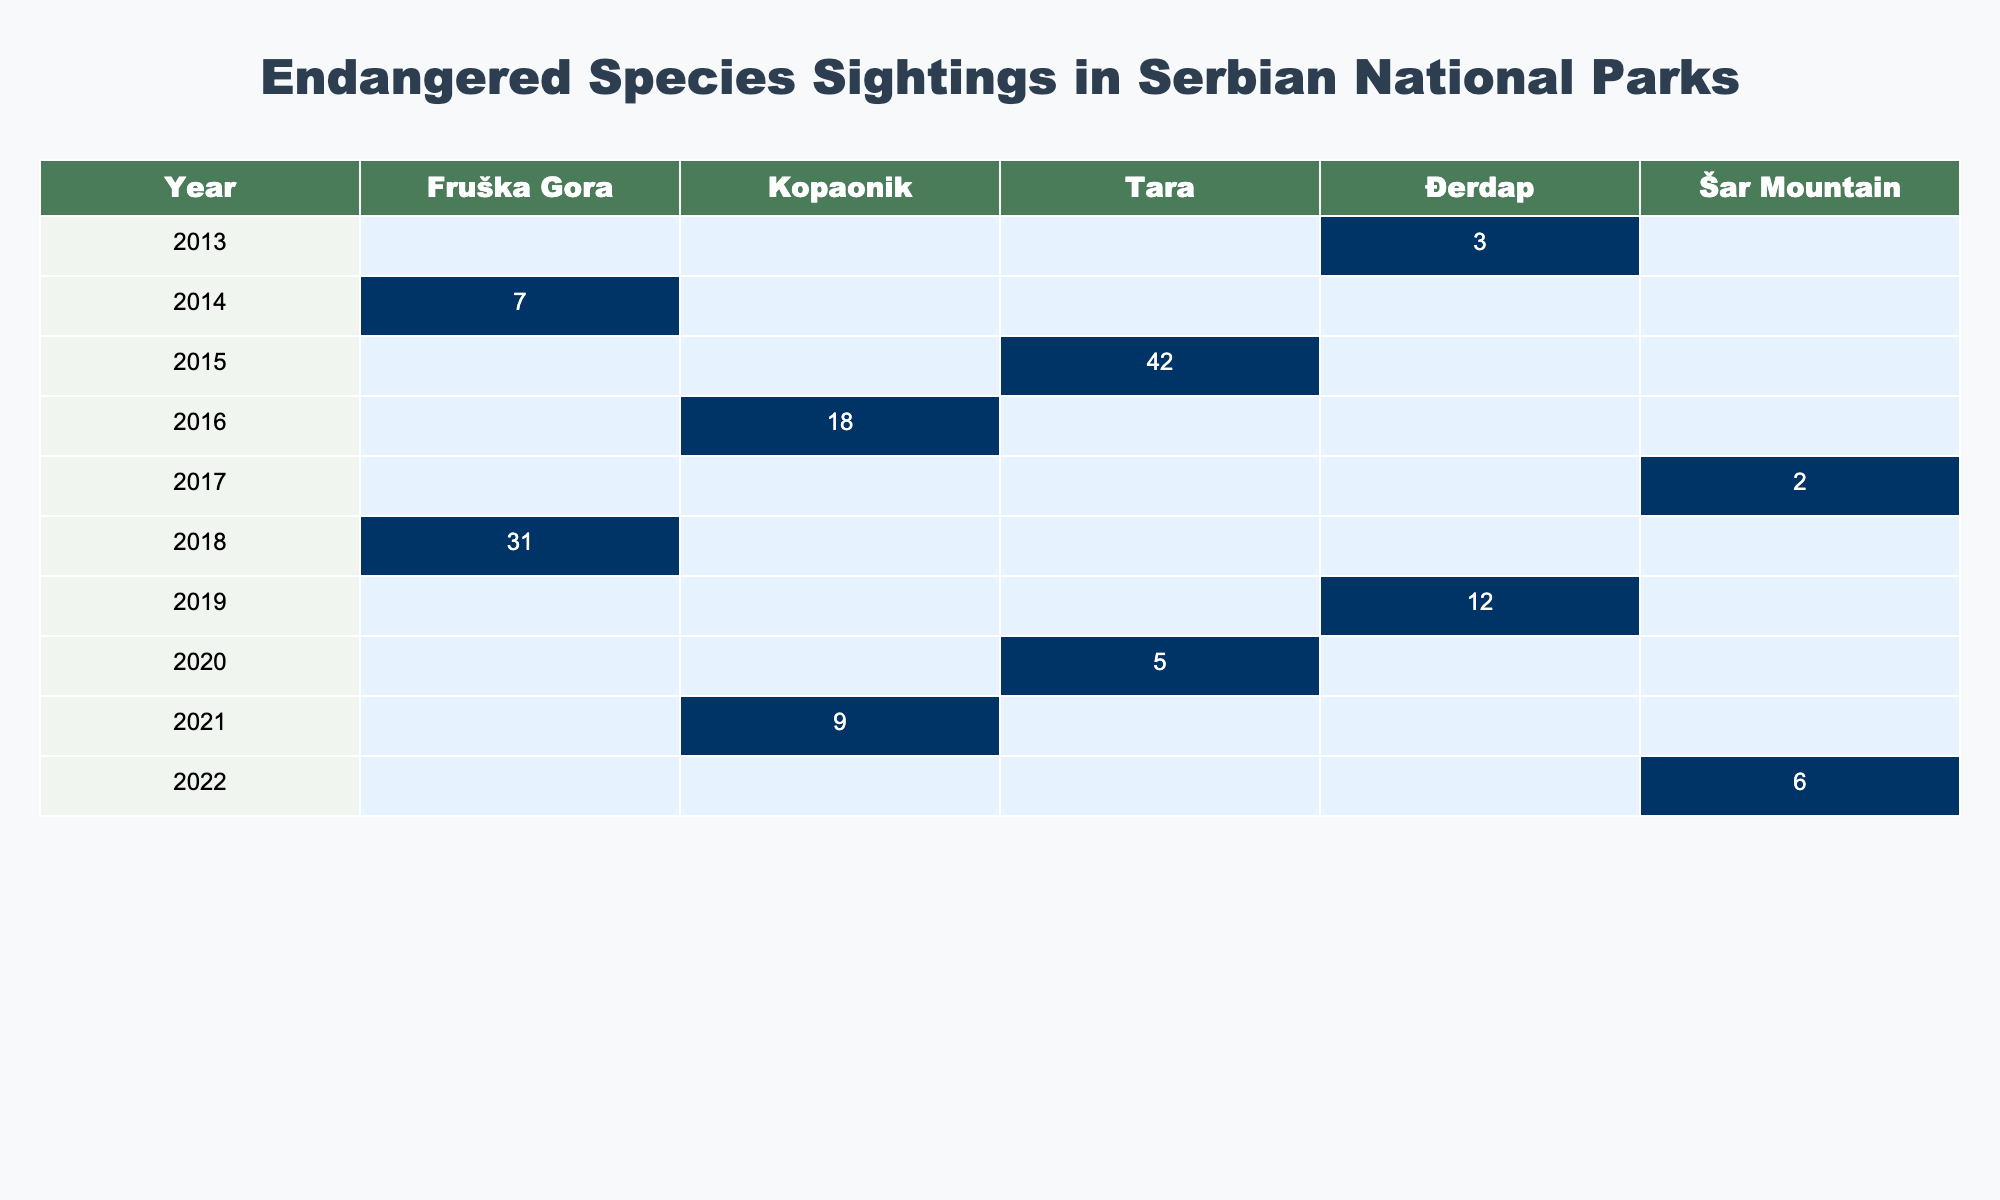What species had the highest number of sightings in 2015? In 2015, the only species recorded was the Serbian Spruce with 42 sightings. Therefore, it had the highest number of sightings that year.
Answer: Serbian Spruce Which national park had the most sightings in 2018? In 2018, Fruška Gora recorded 31 sightings, which is more than any other national park that year.
Answer: Fruška Gora How many total sightings were reported across all national parks in 2014? In 2014, only one species was reported in one park (Fruška Gora) with 7 sightings. So, the total for that year is 7.
Answer: 7 Was there any sighting of Brown Bear in the national parks before 2020? The table shows that Brown Bear was only recorded in 2020 with 5 sightings, meaning there were no sightings before that year.
Answer: No Which species had the least sightings in 2017? In 2017, the Balkan Lynx had the least sightings with only 2 recorded sightings in Šar Mountain.
Answer: Balkan Lynx What is the average number of sightings per year over the entire dataset? The total sightings across all years is (3 + 7 + 42 + 18 + 2 + 31 + 12 + 5 + 9 + 6) = 135. There are 10 years, so the average is 135/10 = 13.5.
Answer: 13.5 In which year did Đerdap have a sighting of the European Otter? According to the table, Đerdap had a sighting of the European Otter in 2019, where it recorded 12 sightings of that species.
Answer: 2019 Which national park recorded sightings in every year represented in the table? The data shows that only Fruška Gora has sightings in two years (2014 and 2018), while other parks have sightings spread across different years. Therefore, no national park recorded sightings in every single year.
Answer: No national park What was the change in the number of sightings from 2013 to 2022? In 2013, there were 3 sightings, and in 2022, there were 6. The change is thus 6 - 3 = 3, indicating an increase of 3 sightings over the years.
Answer: 3 Which species had sightings in both Kopaonik and Šar Mountain? From the table, Ural Owl was sighted in Kopaonik in 2021, and there were no sightings of any species in Šar Mountain that overlaps with Kopaonik's sightings according to this dataset, indicating none had sightings in both parks.
Answer: None 